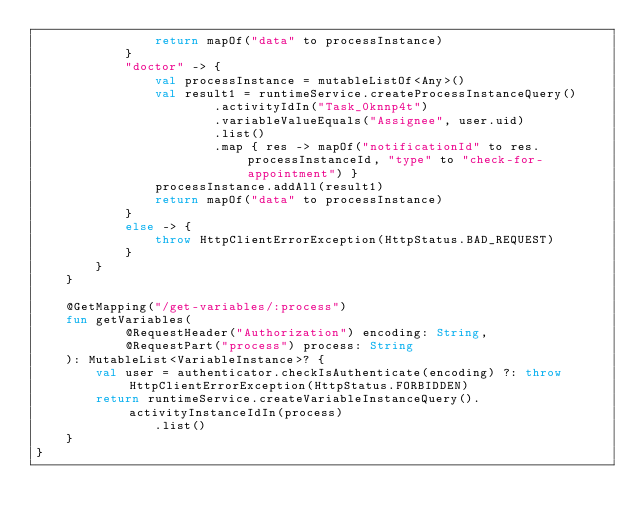Convert code to text. <code><loc_0><loc_0><loc_500><loc_500><_Kotlin_>                return mapOf("data" to processInstance)
            }
            "doctor" -> {
                val processInstance = mutableListOf<Any>()
                val result1 = runtimeService.createProcessInstanceQuery()
                        .activityIdIn("Task_0knnp4t")
                        .variableValueEquals("Assignee", user.uid)
                        .list()
                        .map { res -> mapOf("notificationId" to res.processInstanceId, "type" to "check-for-appointment") }
                processInstance.addAll(result1)
                return mapOf("data" to processInstance)
            }
            else -> {
                throw HttpClientErrorException(HttpStatus.BAD_REQUEST)
            }
        }
    }

    @GetMapping("/get-variables/:process")
    fun getVariables(
            @RequestHeader("Authorization") encoding: String,
            @RequestPart("process") process: String
    ): MutableList<VariableInstance>? {
        val user = authenticator.checkIsAuthenticate(encoding) ?: throw HttpClientErrorException(HttpStatus.FORBIDDEN)
        return runtimeService.createVariableInstanceQuery().activityInstanceIdIn(process)
                .list()
    }
}
</code> 